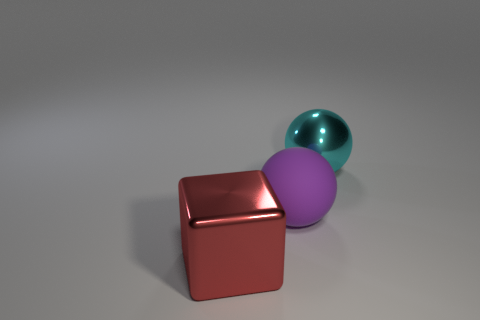Is there another object that has the same material as the big cyan thing?
Provide a succinct answer. Yes. What is the shape of the big red metallic object?
Offer a very short reply. Cube. What is the color of the sphere that is the same material as the big red cube?
Provide a succinct answer. Cyan. How many purple objects are either large rubber spheres or big shiny things?
Provide a succinct answer. 1. Are there more blue shiny cubes than large purple objects?
Provide a short and direct response. No. How many objects are big objects that are right of the cube or large objects behind the large matte sphere?
Make the answer very short. 2. What is the color of the shiny thing that is the same size as the cyan sphere?
Keep it short and to the point. Red. Is the big cube made of the same material as the big cyan sphere?
Your response must be concise. Yes. There is a red cube that is left of the big metal object behind the red shiny thing; what is it made of?
Offer a terse response. Metal. Is the number of big red metal cubes left of the shiny block greater than the number of big red shiny objects?
Provide a succinct answer. No. 